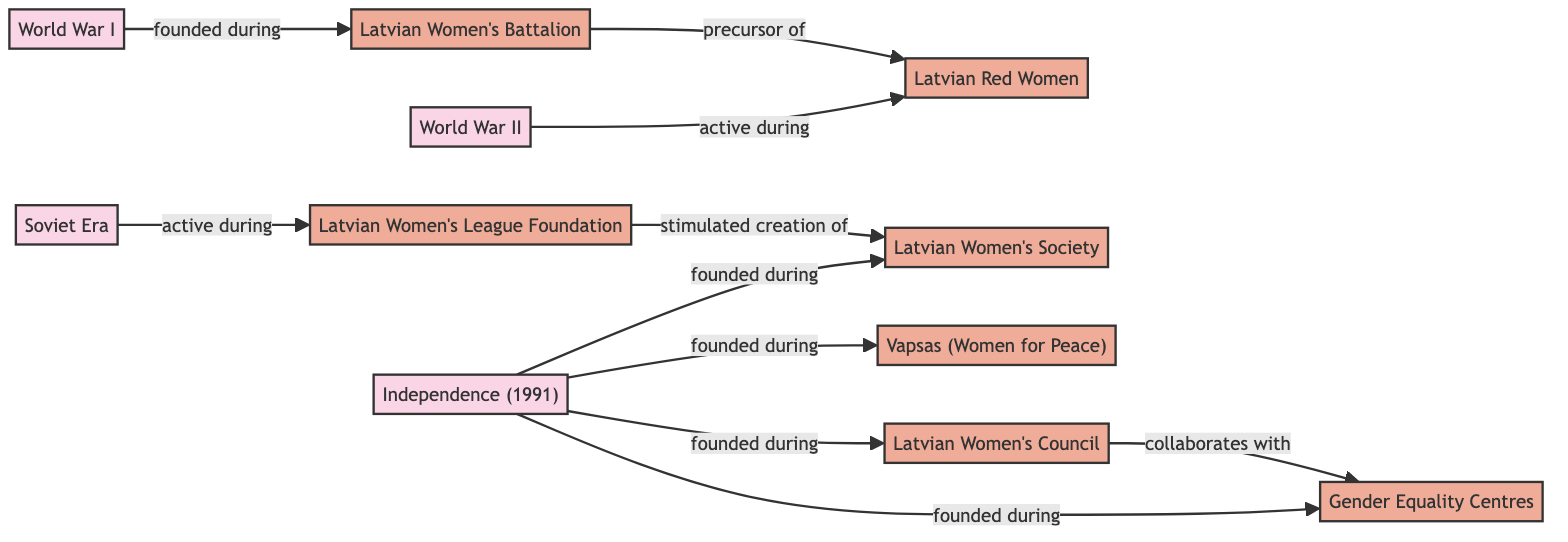What organization was founded during World War I? The diagram shows a directed link from World War I to the Latvian Women's Battalion labeled "founded during," indicating that the Latvian Women's Battalion was established in this historical period.
Answer: Latvian Women's Battalion Which organization was active during World War II? According to the diagram, there is a link from World War II to the Latvian Red Women labeled "active during," which indicates that this organization was active at that time.
Answer: Latvian Red Women How many organizations were founded during the Independence period in 1991? The diagram shows four directed links from the Independence (1991) node to four different organizations. This indicates that four organizations were founded during this period.
Answer: 4 What does the connection between the Latvian Women's League Foundation and the Latvian Women's Society indicate? There is a directed link from the Latvian Women's League Foundation to the Latvian Women's Society labeled "stimulated creation of," which means that the former played a role in the establishment of the latter.
Answer: stimulated creation of Which organization collaborates with the Gender Equality Centres? The diagram shows a directed link from the Latvian Women's Council to the Gender Equality Centres labeled "collaborates with," indicating that these two organizations work together.
Answer: Latvian Women's Council 